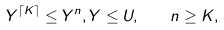<formula> <loc_0><loc_0><loc_500><loc_500>Y ^ { \lceil K \rceil } \leq Y ^ { n } , Y \leq U , \quad n \geq K ,</formula> 